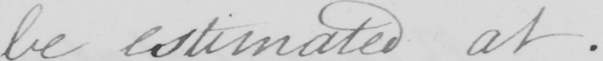What does this handwritten line say? be estimated at . 